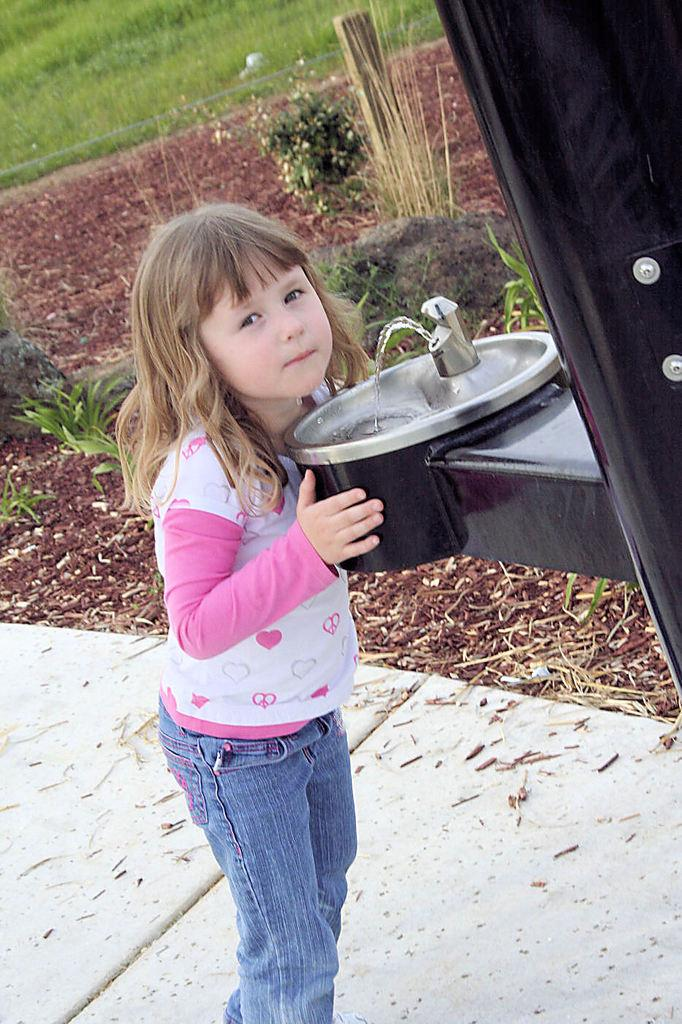What is the main subject of the image? There is a child in the image. Where is the child located in the image? The child is standing in front of a sink. What can be seen in the background or surrounding area of the image? There are plants visible in the image, and there is grass on a surface. What type of tax is being discussed by the child in the image? There is no discussion of tax in the image, as it features a child standing in front of a sink with plants and grass visible in the background. 